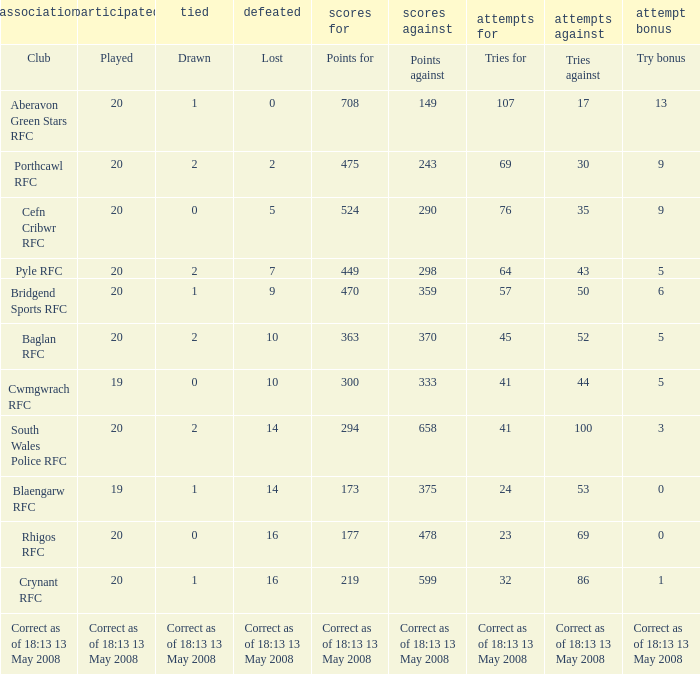What is the tries against when the points are 475? 30.0. 